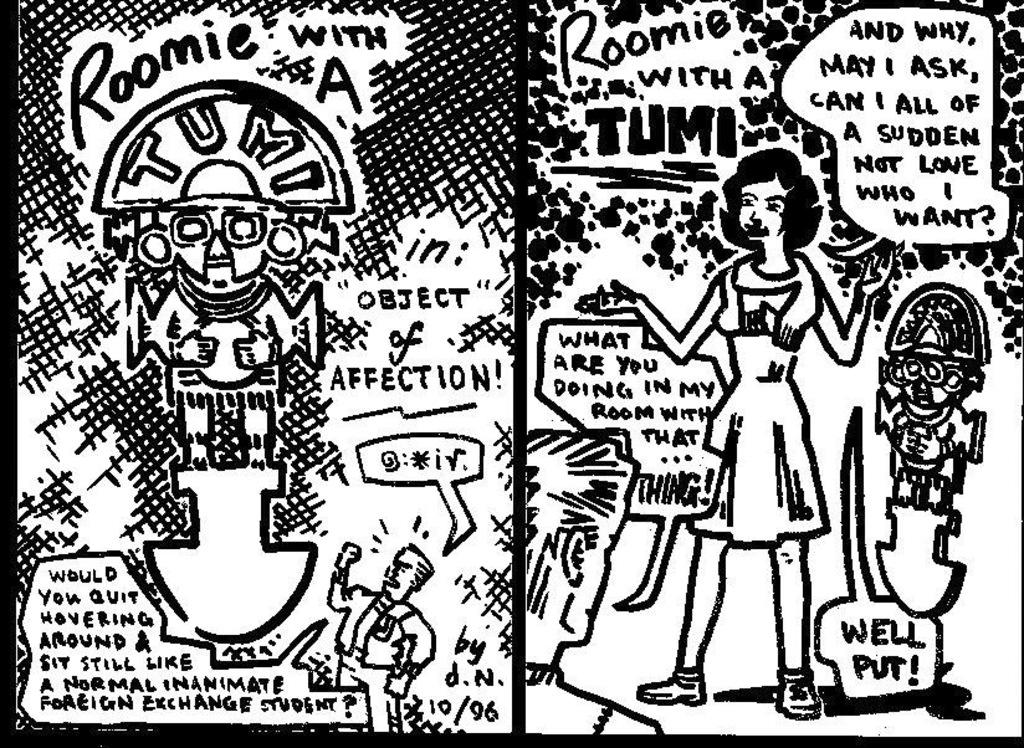What type of visual is the image? The image is a poster. What is the main subject of the poster? There is a woman standing in the image. Are there any additional objects or elements in the poster? There might be toys in the image. Is there any text present on the poster? Yes, there is text in the image. How many persons are standing in the image? There are two persons standing in the image. Can you tell me what type of quince is being used as a prop in the image? There is no quince present in the image. Is there a school visible in the background of the image? The image does not show a school or any background elements. 